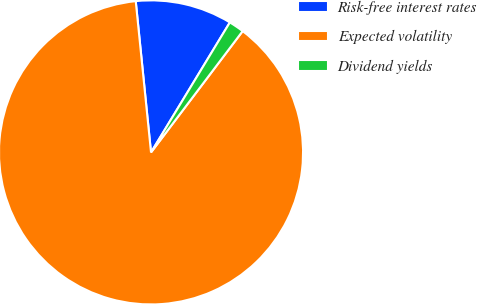Convert chart to OTSL. <chart><loc_0><loc_0><loc_500><loc_500><pie_chart><fcel>Risk-free interest rates<fcel>Expected volatility<fcel>Dividend yields<nl><fcel>10.28%<fcel>88.1%<fcel>1.62%<nl></chart> 